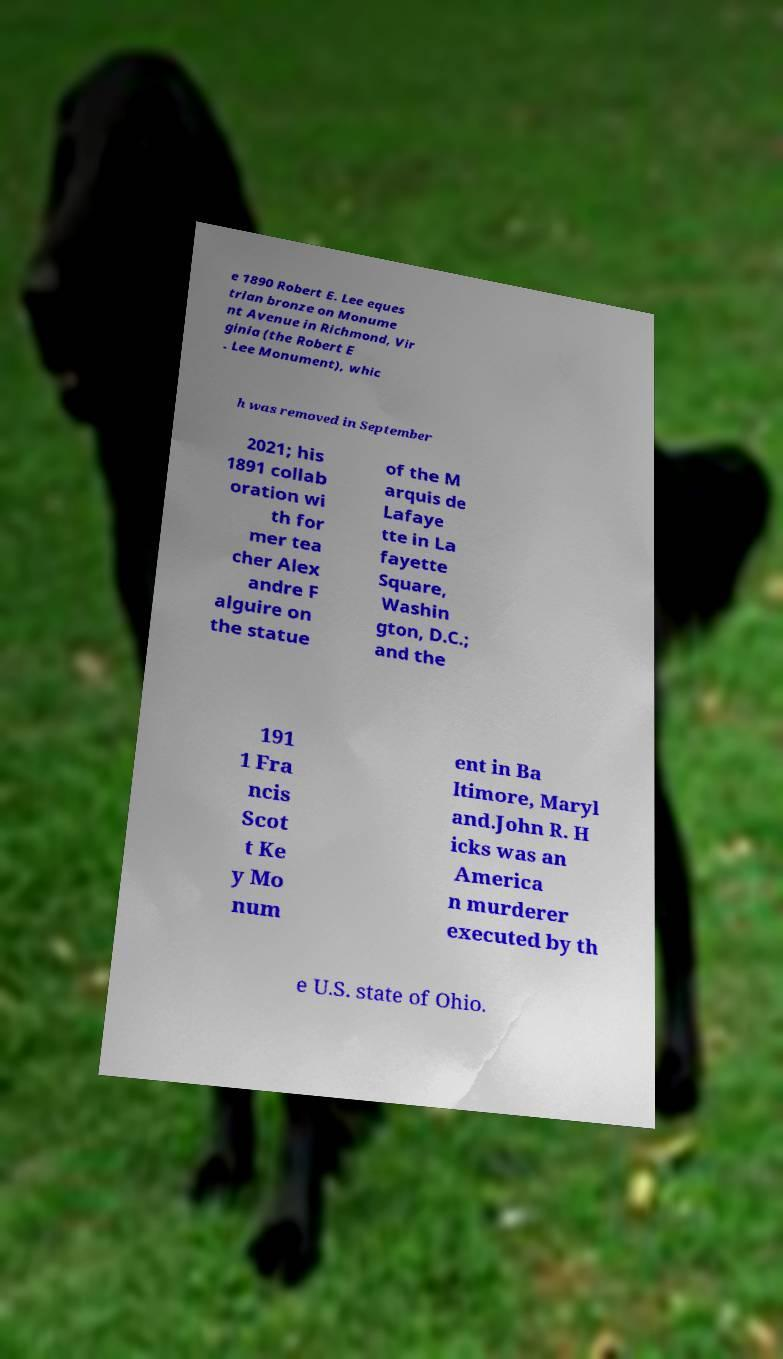There's text embedded in this image that I need extracted. Can you transcribe it verbatim? e 1890 Robert E. Lee eques trian bronze on Monume nt Avenue in Richmond, Vir ginia (the Robert E . Lee Monument), whic h was removed in September 2021; his 1891 collab oration wi th for mer tea cher Alex andre F alguire on the statue of the M arquis de Lafaye tte in La fayette Square, Washin gton, D.C.; and the 191 1 Fra ncis Scot t Ke y Mo num ent in Ba ltimore, Maryl and.John R. H icks was an America n murderer executed by th e U.S. state of Ohio. 